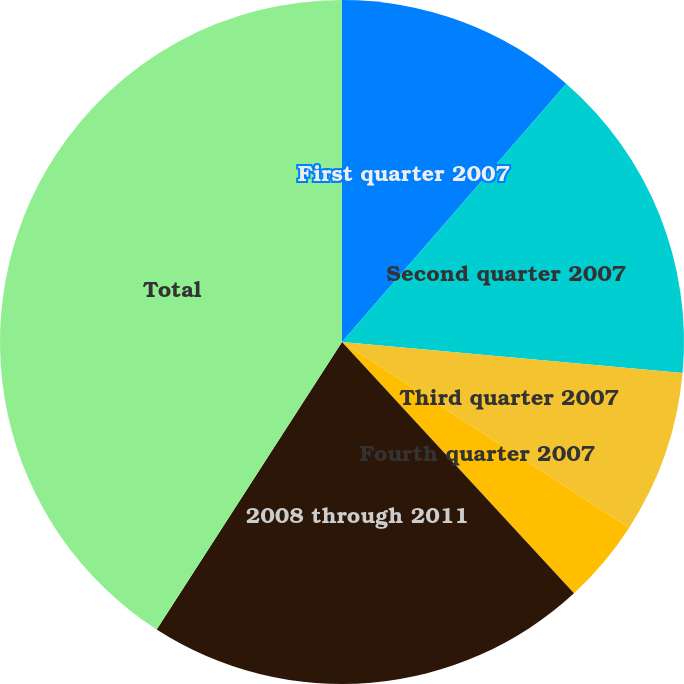Convert chart. <chart><loc_0><loc_0><loc_500><loc_500><pie_chart><fcel>First quarter 2007<fcel>Second quarter 2007<fcel>Third quarter 2007<fcel>Fourth quarter 2007<fcel>2008 through 2011<fcel>Total<nl><fcel>11.38%<fcel>15.07%<fcel>7.69%<fcel>4.0%<fcel>20.98%<fcel>40.89%<nl></chart> 